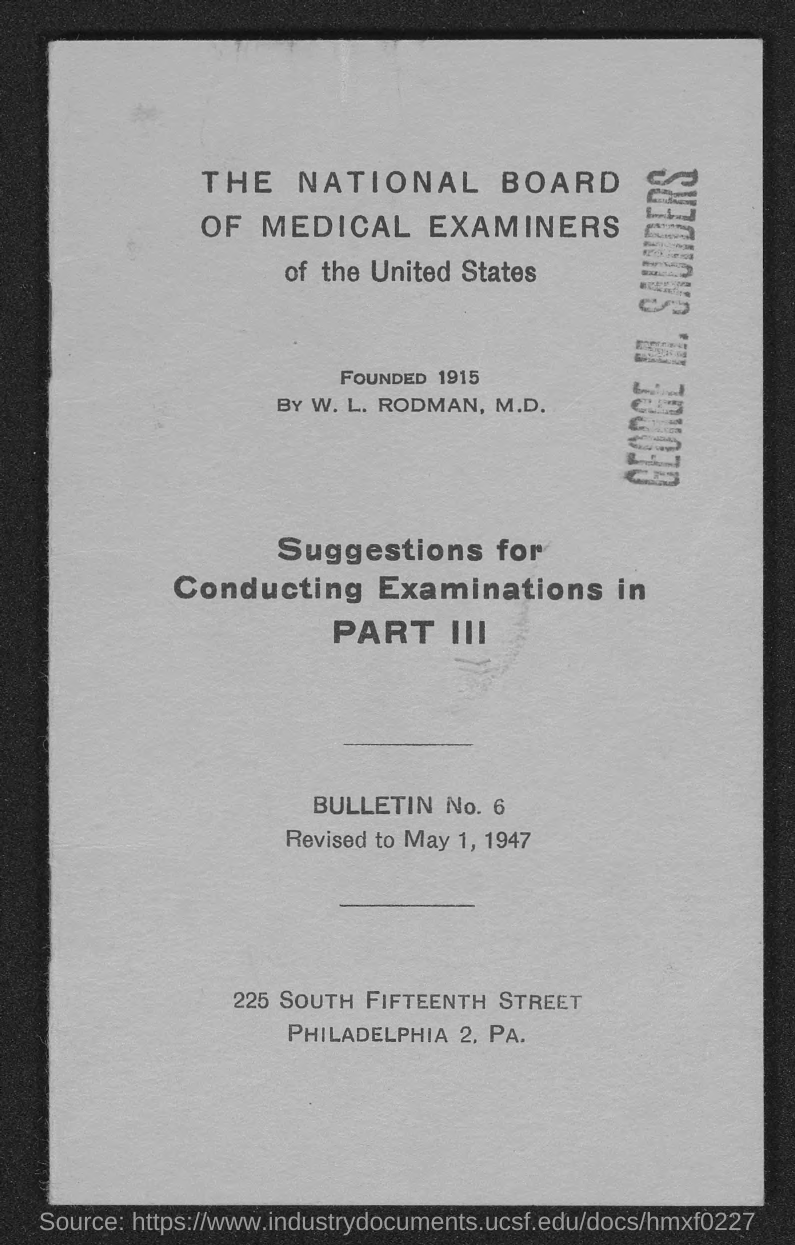When was the National Board of Medical Examiners of the United States founded?
Offer a terse response. Founded 1915. 